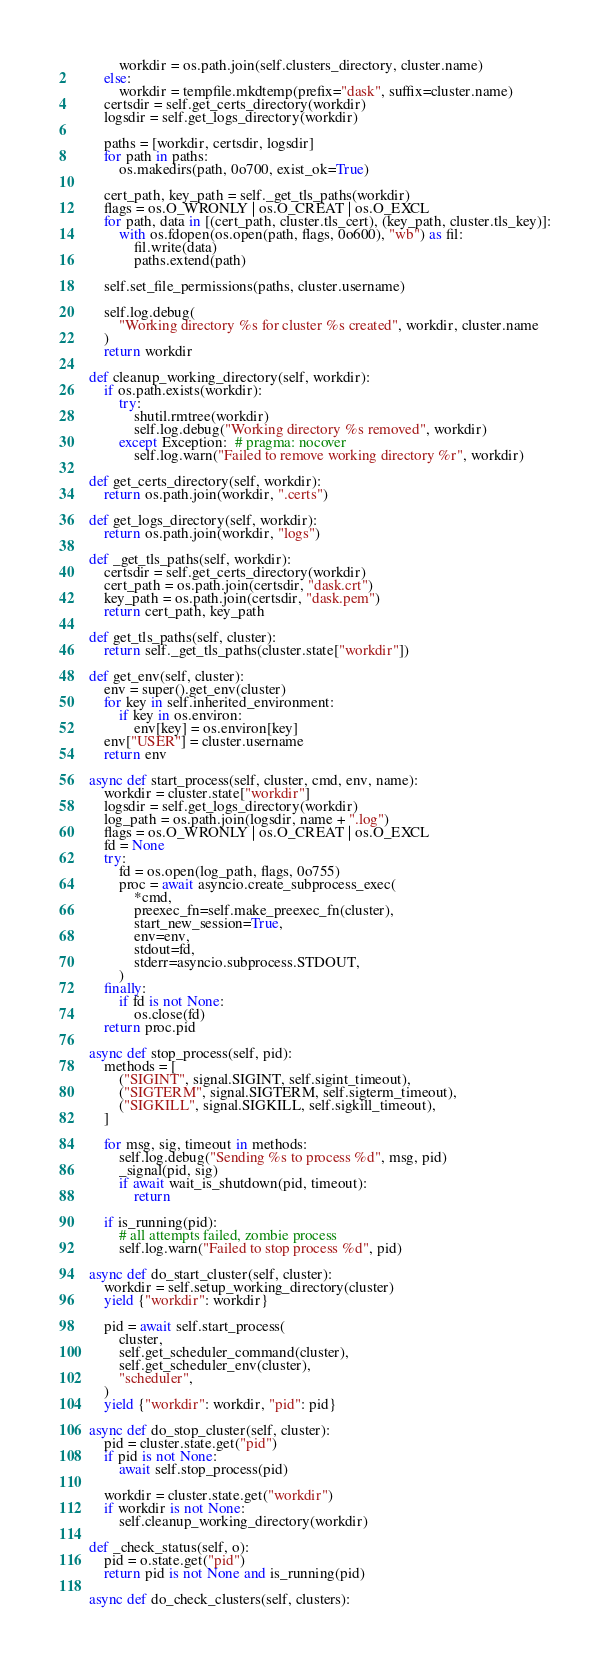<code> <loc_0><loc_0><loc_500><loc_500><_Python_>            workdir = os.path.join(self.clusters_directory, cluster.name)
        else:
            workdir = tempfile.mkdtemp(prefix="dask", suffix=cluster.name)
        certsdir = self.get_certs_directory(workdir)
        logsdir = self.get_logs_directory(workdir)

        paths = [workdir, certsdir, logsdir]
        for path in paths:
            os.makedirs(path, 0o700, exist_ok=True)

        cert_path, key_path = self._get_tls_paths(workdir)
        flags = os.O_WRONLY | os.O_CREAT | os.O_EXCL
        for path, data in [(cert_path, cluster.tls_cert), (key_path, cluster.tls_key)]:
            with os.fdopen(os.open(path, flags, 0o600), "wb") as fil:
                fil.write(data)
                paths.extend(path)

        self.set_file_permissions(paths, cluster.username)

        self.log.debug(
            "Working directory %s for cluster %s created", workdir, cluster.name
        )
        return workdir

    def cleanup_working_directory(self, workdir):
        if os.path.exists(workdir):
            try:
                shutil.rmtree(workdir)
                self.log.debug("Working directory %s removed", workdir)
            except Exception:  # pragma: nocover
                self.log.warn("Failed to remove working directory %r", workdir)

    def get_certs_directory(self, workdir):
        return os.path.join(workdir, ".certs")

    def get_logs_directory(self, workdir):
        return os.path.join(workdir, "logs")

    def _get_tls_paths(self, workdir):
        certsdir = self.get_certs_directory(workdir)
        cert_path = os.path.join(certsdir, "dask.crt")
        key_path = os.path.join(certsdir, "dask.pem")
        return cert_path, key_path

    def get_tls_paths(self, cluster):
        return self._get_tls_paths(cluster.state["workdir"])

    def get_env(self, cluster):
        env = super().get_env(cluster)
        for key in self.inherited_environment:
            if key in os.environ:
                env[key] = os.environ[key]
        env["USER"] = cluster.username
        return env

    async def start_process(self, cluster, cmd, env, name):
        workdir = cluster.state["workdir"]
        logsdir = self.get_logs_directory(workdir)
        log_path = os.path.join(logsdir, name + ".log")
        flags = os.O_WRONLY | os.O_CREAT | os.O_EXCL
        fd = None
        try:
            fd = os.open(log_path, flags, 0o755)
            proc = await asyncio.create_subprocess_exec(
                *cmd,
                preexec_fn=self.make_preexec_fn(cluster),
                start_new_session=True,
                env=env,
                stdout=fd,
                stderr=asyncio.subprocess.STDOUT,
            )
        finally:
            if fd is not None:
                os.close(fd)
        return proc.pid

    async def stop_process(self, pid):
        methods = [
            ("SIGINT", signal.SIGINT, self.sigint_timeout),
            ("SIGTERM", signal.SIGTERM, self.sigterm_timeout),
            ("SIGKILL", signal.SIGKILL, self.sigkill_timeout),
        ]

        for msg, sig, timeout in methods:
            self.log.debug("Sending %s to process %d", msg, pid)
            _signal(pid, sig)
            if await wait_is_shutdown(pid, timeout):
                return

        if is_running(pid):
            # all attempts failed, zombie process
            self.log.warn("Failed to stop process %d", pid)

    async def do_start_cluster(self, cluster):
        workdir = self.setup_working_directory(cluster)
        yield {"workdir": workdir}

        pid = await self.start_process(
            cluster,
            self.get_scheduler_command(cluster),
            self.get_scheduler_env(cluster),
            "scheduler",
        )
        yield {"workdir": workdir, "pid": pid}

    async def do_stop_cluster(self, cluster):
        pid = cluster.state.get("pid")
        if pid is not None:
            await self.stop_process(pid)

        workdir = cluster.state.get("workdir")
        if workdir is not None:
            self.cleanup_working_directory(workdir)

    def _check_status(self, o):
        pid = o.state.get("pid")
        return pid is not None and is_running(pid)

    async def do_check_clusters(self, clusters):</code> 